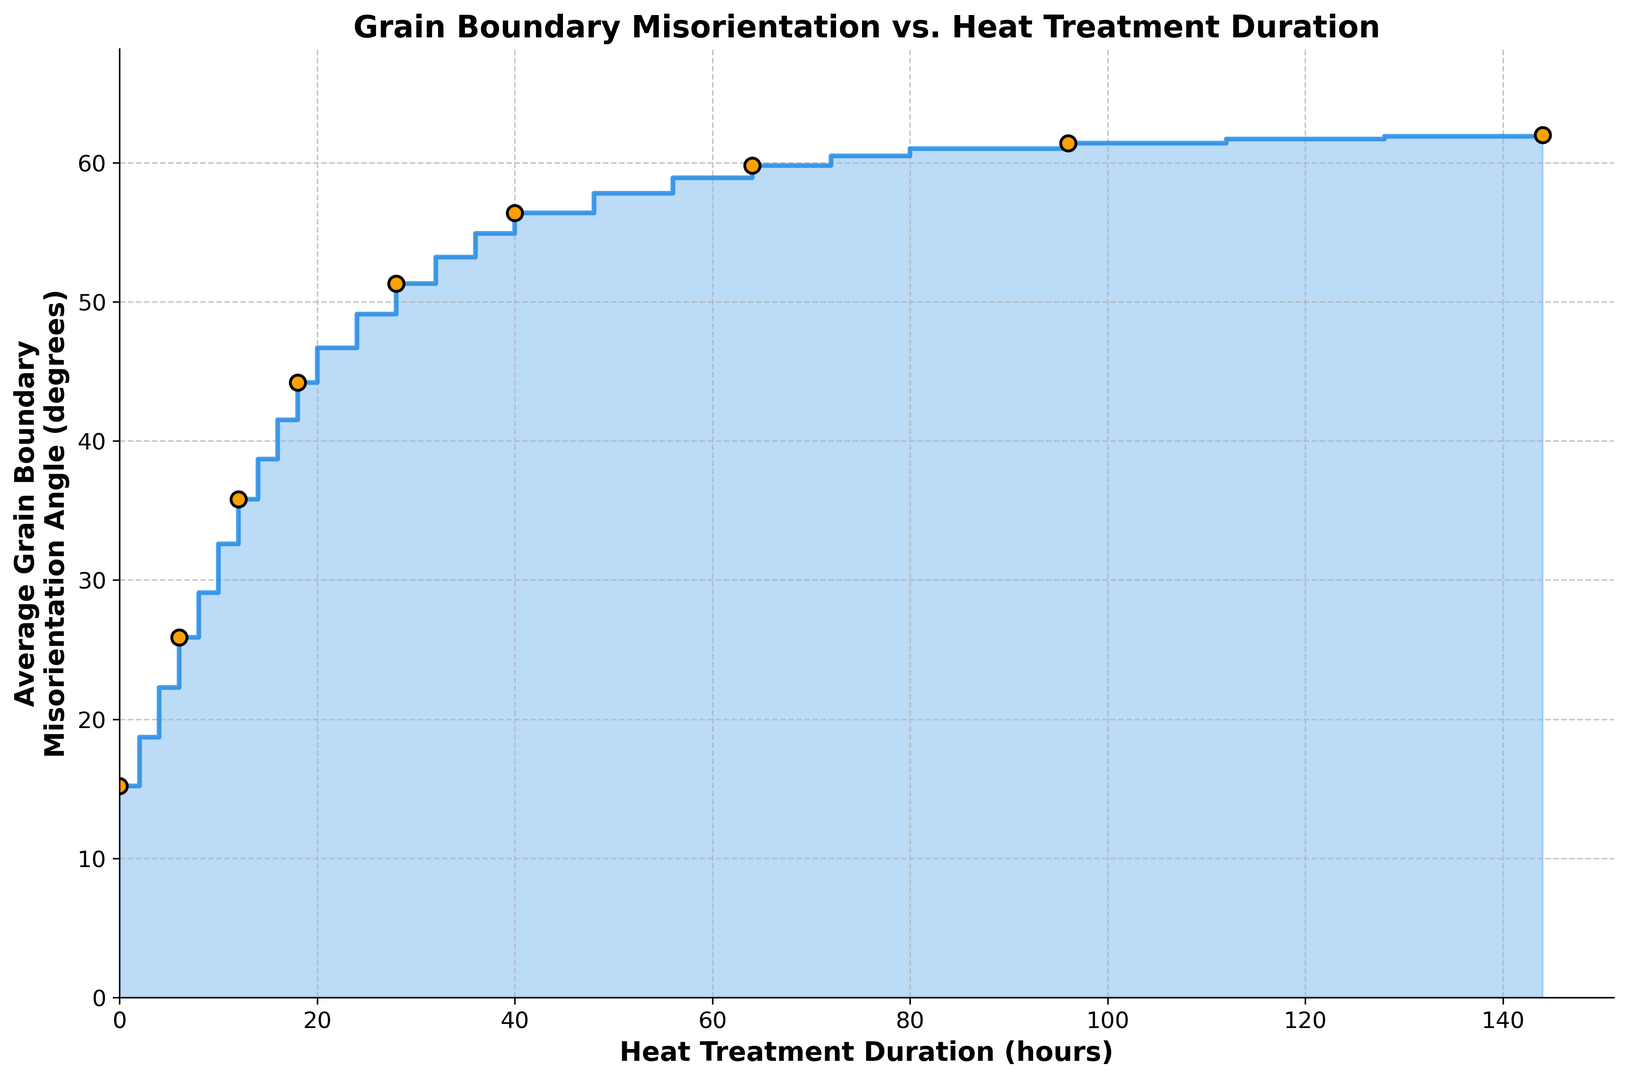What's the initial average grain boundary misorientation angle before any heat treatment? Observe the y-axis value at the x-axis point corresponding to 0 hours of heat treatment. The value is 15.2 degrees.
Answer: 15.2 degrees How much does the average grain boundary misorientation angle increase after 10 hours of heat treatment? Check the y-values at 0 hours (15.2 degrees) and 10 hours (32.6 degrees). The difference is 32.6 - 15.2.
Answer: 17.4 degrees At what heat treatment duration does the average grain boundary misorientation angle first exceed 50 degrees? Identify the point on the x-axis where the y-value exceeds 50 degrees for the first time. It occurs at 28 hours (y = 51.3 degrees).
Answer: 28 hours Is there a point where the average grain boundary misorientation angle stops increasing significantly? If so, where? Examine the y-values after each interval. The increase slows down significantly after 64 hours, hovering around 61.0 degrees from 80 to 144 hours.
Answer: 64 hours How does the rate of increase in misorientation angle between 0 to 10 hours compare to 10 to 20 hours? Calculate the differences for each interval (32.6 - 15.2 = 17.4 degrees for 0 to 10 hours, and 46.7 - 32.6 = 14.1 degrees for 10 to 20 hours). The rate of increase is higher in the first interval.
Answer: Higher in the first interval What is the average of the misorientation angles over the 24-hour and 48-hour heat treatment marks? Add the y-values at 24 (49.1 degrees) and 48 hours (57.8 degrees) and divide by 2. (49.1 + 57.8) / 2 = 53.45 degrees.
Answer: 53.45 degrees Compare the average grain boundary misorientation angle at 72 hours with the value at 96 hours. Which one is greater and by how much? Find the y-values at 72 hours (60.5 degrees) and 96 hours (61.4 degrees). The difference is 61.4 - 60.5.
Answer: 96 hours by 0.9 degrees What is the highest average grain boundary misorientation angle observed, and at what duration? Look for the maximum y-value in the data, which is 62.0 degrees, occurring at 144 hours.
Answer: 62.0 degrees at 144 hours Identify the points where markers are placed on the plot. Markers are added every 3rd point, so check x-axis values: 0, 6, 12, 18, 24, 30, 36, 42, 48, 54, 60, 66, 72, 78, 84, 90, 96, 102, 108, 114, 120, 126, 132, 138, 144 hours.
Answer: Every 6 hours What is the pattern of grain boundary misorientation angle change as the heat treatment duration increases? Observe the general trend: steep increase initially, which gradually slows down, displaying a clear saturating trend after around 64 hours.
Answer: Increasing, then saturating 